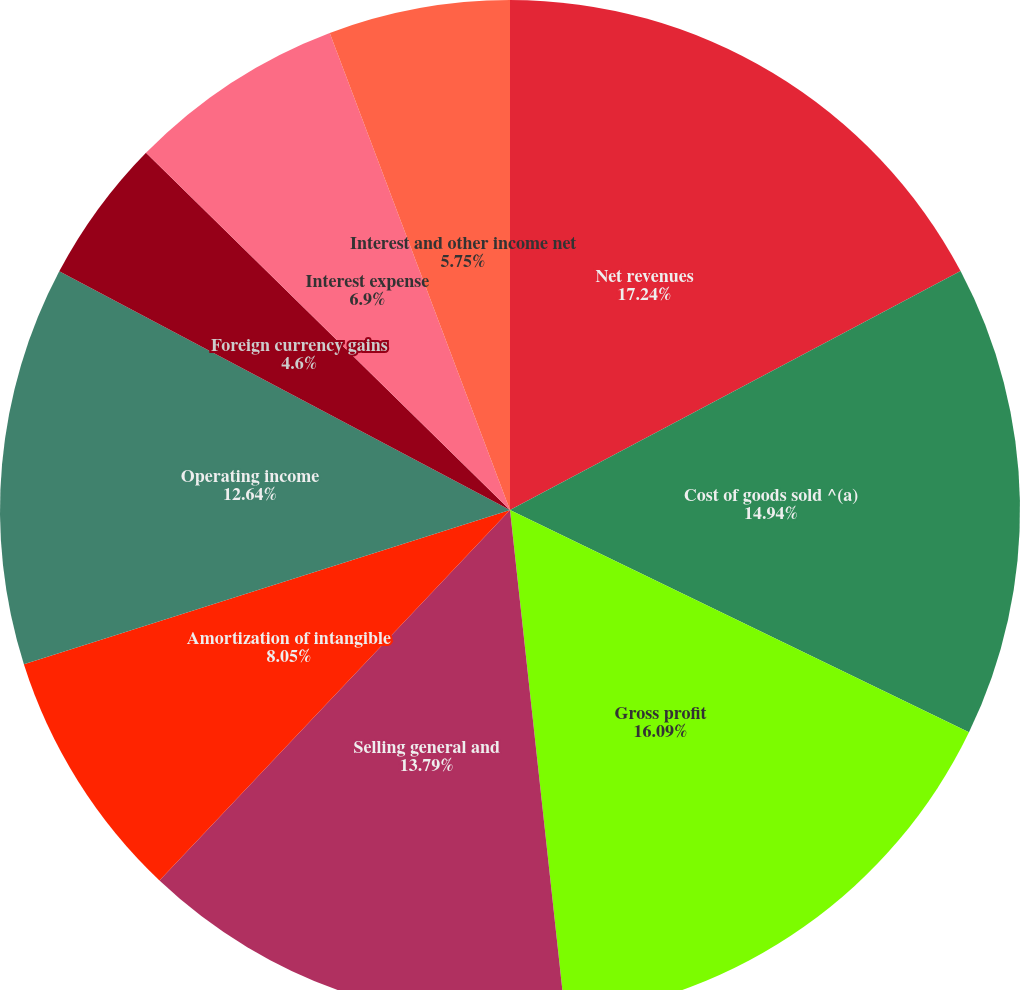<chart> <loc_0><loc_0><loc_500><loc_500><pie_chart><fcel>Net revenues<fcel>Cost of goods sold ^(a)<fcel>Gross profit<fcel>Selling general and<fcel>Amortization of intangible<fcel>Operating income<fcel>Foreign currency gains<fcel>Interest expense<fcel>Interest and other income net<fcel>Equity in income (loss) of<nl><fcel>17.24%<fcel>14.94%<fcel>16.09%<fcel>13.79%<fcel>8.05%<fcel>12.64%<fcel>4.6%<fcel>6.9%<fcel>5.75%<fcel>0.0%<nl></chart> 